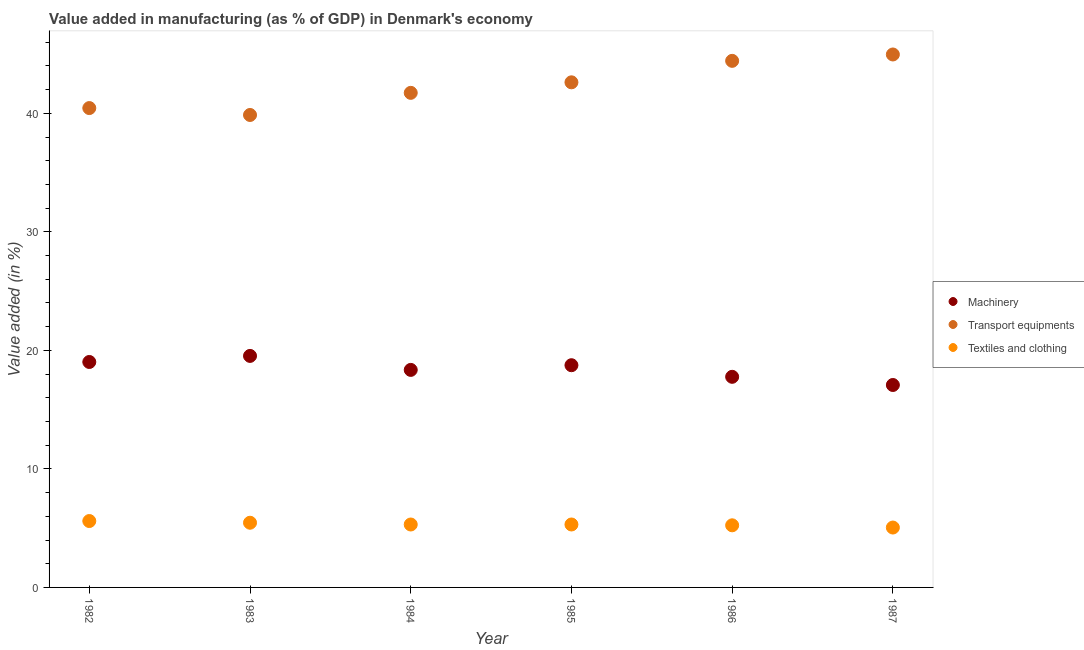What is the value added in manufacturing textile and clothing in 1986?
Make the answer very short. 5.24. Across all years, what is the maximum value added in manufacturing machinery?
Offer a terse response. 19.53. Across all years, what is the minimum value added in manufacturing machinery?
Ensure brevity in your answer.  17.08. In which year was the value added in manufacturing textile and clothing maximum?
Make the answer very short. 1982. What is the total value added in manufacturing textile and clothing in the graph?
Offer a terse response. 31.97. What is the difference between the value added in manufacturing transport equipments in 1982 and that in 1986?
Keep it short and to the point. -3.98. What is the difference between the value added in manufacturing textile and clothing in 1982 and the value added in manufacturing machinery in 1987?
Provide a short and direct response. -11.48. What is the average value added in manufacturing machinery per year?
Ensure brevity in your answer.  18.42. In the year 1986, what is the difference between the value added in manufacturing machinery and value added in manufacturing textile and clothing?
Provide a short and direct response. 12.53. What is the ratio of the value added in manufacturing textile and clothing in 1983 to that in 1986?
Offer a terse response. 1.04. Is the value added in manufacturing textile and clothing in 1984 less than that in 1986?
Offer a terse response. No. What is the difference between the highest and the second highest value added in manufacturing textile and clothing?
Ensure brevity in your answer.  0.14. What is the difference between the highest and the lowest value added in manufacturing machinery?
Your answer should be very brief. 2.45. In how many years, is the value added in manufacturing transport equipments greater than the average value added in manufacturing transport equipments taken over all years?
Make the answer very short. 3. How many dotlines are there?
Your answer should be very brief. 3. What is the difference between two consecutive major ticks on the Y-axis?
Your answer should be compact. 10. Does the graph contain grids?
Provide a short and direct response. No. How many legend labels are there?
Make the answer very short. 3. What is the title of the graph?
Keep it short and to the point. Value added in manufacturing (as % of GDP) in Denmark's economy. Does "Argument" appear as one of the legend labels in the graph?
Ensure brevity in your answer.  No. What is the label or title of the Y-axis?
Ensure brevity in your answer.  Value added (in %). What is the Value added (in %) of Machinery in 1982?
Offer a very short reply. 19.02. What is the Value added (in %) of Transport equipments in 1982?
Provide a short and direct response. 40.44. What is the Value added (in %) of Textiles and clothing in 1982?
Provide a succinct answer. 5.6. What is the Value added (in %) of Machinery in 1983?
Offer a very short reply. 19.53. What is the Value added (in %) in Transport equipments in 1983?
Your response must be concise. 39.86. What is the Value added (in %) in Textiles and clothing in 1983?
Your answer should be very brief. 5.46. What is the Value added (in %) in Machinery in 1984?
Ensure brevity in your answer.  18.35. What is the Value added (in %) of Transport equipments in 1984?
Ensure brevity in your answer.  41.73. What is the Value added (in %) in Textiles and clothing in 1984?
Your response must be concise. 5.31. What is the Value added (in %) of Machinery in 1985?
Your answer should be compact. 18.75. What is the Value added (in %) of Transport equipments in 1985?
Your answer should be very brief. 42.61. What is the Value added (in %) in Textiles and clothing in 1985?
Provide a succinct answer. 5.31. What is the Value added (in %) in Machinery in 1986?
Your answer should be compact. 17.77. What is the Value added (in %) in Transport equipments in 1986?
Make the answer very short. 44.42. What is the Value added (in %) of Textiles and clothing in 1986?
Provide a succinct answer. 5.24. What is the Value added (in %) of Machinery in 1987?
Provide a succinct answer. 17.08. What is the Value added (in %) in Transport equipments in 1987?
Your answer should be very brief. 44.96. What is the Value added (in %) in Textiles and clothing in 1987?
Offer a terse response. 5.05. Across all years, what is the maximum Value added (in %) in Machinery?
Keep it short and to the point. 19.53. Across all years, what is the maximum Value added (in %) in Transport equipments?
Make the answer very short. 44.96. Across all years, what is the maximum Value added (in %) in Textiles and clothing?
Make the answer very short. 5.6. Across all years, what is the minimum Value added (in %) in Machinery?
Your response must be concise. 17.08. Across all years, what is the minimum Value added (in %) in Transport equipments?
Give a very brief answer. 39.86. Across all years, what is the minimum Value added (in %) of Textiles and clothing?
Offer a very short reply. 5.05. What is the total Value added (in %) in Machinery in the graph?
Offer a very short reply. 110.5. What is the total Value added (in %) of Transport equipments in the graph?
Keep it short and to the point. 254.02. What is the total Value added (in %) in Textiles and clothing in the graph?
Keep it short and to the point. 31.97. What is the difference between the Value added (in %) in Machinery in 1982 and that in 1983?
Your response must be concise. -0.51. What is the difference between the Value added (in %) in Transport equipments in 1982 and that in 1983?
Offer a very short reply. 0.58. What is the difference between the Value added (in %) in Textiles and clothing in 1982 and that in 1983?
Keep it short and to the point. 0.14. What is the difference between the Value added (in %) of Machinery in 1982 and that in 1984?
Make the answer very short. 0.67. What is the difference between the Value added (in %) of Transport equipments in 1982 and that in 1984?
Your response must be concise. -1.28. What is the difference between the Value added (in %) of Textiles and clothing in 1982 and that in 1984?
Make the answer very short. 0.29. What is the difference between the Value added (in %) of Machinery in 1982 and that in 1985?
Give a very brief answer. 0.27. What is the difference between the Value added (in %) in Transport equipments in 1982 and that in 1985?
Provide a succinct answer. -2.17. What is the difference between the Value added (in %) of Textiles and clothing in 1982 and that in 1985?
Keep it short and to the point. 0.29. What is the difference between the Value added (in %) in Machinery in 1982 and that in 1986?
Make the answer very short. 1.25. What is the difference between the Value added (in %) of Transport equipments in 1982 and that in 1986?
Offer a very short reply. -3.98. What is the difference between the Value added (in %) in Textiles and clothing in 1982 and that in 1986?
Ensure brevity in your answer.  0.36. What is the difference between the Value added (in %) of Machinery in 1982 and that in 1987?
Make the answer very short. 1.94. What is the difference between the Value added (in %) in Transport equipments in 1982 and that in 1987?
Your answer should be compact. -4.52. What is the difference between the Value added (in %) in Textiles and clothing in 1982 and that in 1987?
Offer a terse response. 0.55. What is the difference between the Value added (in %) of Machinery in 1983 and that in 1984?
Provide a succinct answer. 1.18. What is the difference between the Value added (in %) in Transport equipments in 1983 and that in 1984?
Give a very brief answer. -1.87. What is the difference between the Value added (in %) of Textiles and clothing in 1983 and that in 1984?
Offer a very short reply. 0.15. What is the difference between the Value added (in %) in Machinery in 1983 and that in 1985?
Your answer should be very brief. 0.79. What is the difference between the Value added (in %) of Transport equipments in 1983 and that in 1985?
Offer a terse response. -2.75. What is the difference between the Value added (in %) in Textiles and clothing in 1983 and that in 1985?
Keep it short and to the point. 0.15. What is the difference between the Value added (in %) of Machinery in 1983 and that in 1986?
Provide a short and direct response. 1.76. What is the difference between the Value added (in %) in Transport equipments in 1983 and that in 1986?
Keep it short and to the point. -4.57. What is the difference between the Value added (in %) of Textiles and clothing in 1983 and that in 1986?
Your answer should be very brief. 0.22. What is the difference between the Value added (in %) in Machinery in 1983 and that in 1987?
Your response must be concise. 2.45. What is the difference between the Value added (in %) in Transport equipments in 1983 and that in 1987?
Ensure brevity in your answer.  -5.1. What is the difference between the Value added (in %) of Textiles and clothing in 1983 and that in 1987?
Offer a terse response. 0.41. What is the difference between the Value added (in %) of Machinery in 1984 and that in 1985?
Offer a very short reply. -0.39. What is the difference between the Value added (in %) in Transport equipments in 1984 and that in 1985?
Ensure brevity in your answer.  -0.89. What is the difference between the Value added (in %) of Textiles and clothing in 1984 and that in 1985?
Offer a very short reply. -0. What is the difference between the Value added (in %) of Machinery in 1984 and that in 1986?
Provide a succinct answer. 0.58. What is the difference between the Value added (in %) in Transport equipments in 1984 and that in 1986?
Keep it short and to the point. -2.7. What is the difference between the Value added (in %) in Textiles and clothing in 1984 and that in 1986?
Make the answer very short. 0.07. What is the difference between the Value added (in %) of Machinery in 1984 and that in 1987?
Your response must be concise. 1.27. What is the difference between the Value added (in %) in Transport equipments in 1984 and that in 1987?
Provide a succinct answer. -3.24. What is the difference between the Value added (in %) of Textiles and clothing in 1984 and that in 1987?
Keep it short and to the point. 0.26. What is the difference between the Value added (in %) of Machinery in 1985 and that in 1986?
Offer a terse response. 0.98. What is the difference between the Value added (in %) of Transport equipments in 1985 and that in 1986?
Provide a succinct answer. -1.81. What is the difference between the Value added (in %) of Textiles and clothing in 1985 and that in 1986?
Provide a succinct answer. 0.07. What is the difference between the Value added (in %) of Machinery in 1985 and that in 1987?
Your answer should be compact. 1.67. What is the difference between the Value added (in %) of Transport equipments in 1985 and that in 1987?
Make the answer very short. -2.35. What is the difference between the Value added (in %) of Textiles and clothing in 1985 and that in 1987?
Your answer should be very brief. 0.26. What is the difference between the Value added (in %) in Machinery in 1986 and that in 1987?
Your answer should be very brief. 0.69. What is the difference between the Value added (in %) in Transport equipments in 1986 and that in 1987?
Keep it short and to the point. -0.54. What is the difference between the Value added (in %) of Textiles and clothing in 1986 and that in 1987?
Offer a very short reply. 0.19. What is the difference between the Value added (in %) of Machinery in 1982 and the Value added (in %) of Transport equipments in 1983?
Offer a very short reply. -20.84. What is the difference between the Value added (in %) in Machinery in 1982 and the Value added (in %) in Textiles and clothing in 1983?
Your answer should be compact. 13.56. What is the difference between the Value added (in %) in Transport equipments in 1982 and the Value added (in %) in Textiles and clothing in 1983?
Provide a succinct answer. 34.98. What is the difference between the Value added (in %) of Machinery in 1982 and the Value added (in %) of Transport equipments in 1984?
Provide a succinct answer. -22.71. What is the difference between the Value added (in %) in Machinery in 1982 and the Value added (in %) in Textiles and clothing in 1984?
Provide a short and direct response. 13.71. What is the difference between the Value added (in %) in Transport equipments in 1982 and the Value added (in %) in Textiles and clothing in 1984?
Your answer should be compact. 35.13. What is the difference between the Value added (in %) in Machinery in 1982 and the Value added (in %) in Transport equipments in 1985?
Provide a succinct answer. -23.59. What is the difference between the Value added (in %) in Machinery in 1982 and the Value added (in %) in Textiles and clothing in 1985?
Provide a short and direct response. 13.71. What is the difference between the Value added (in %) in Transport equipments in 1982 and the Value added (in %) in Textiles and clothing in 1985?
Your answer should be very brief. 35.13. What is the difference between the Value added (in %) in Machinery in 1982 and the Value added (in %) in Transport equipments in 1986?
Offer a very short reply. -25.4. What is the difference between the Value added (in %) in Machinery in 1982 and the Value added (in %) in Textiles and clothing in 1986?
Your answer should be very brief. 13.78. What is the difference between the Value added (in %) in Transport equipments in 1982 and the Value added (in %) in Textiles and clothing in 1986?
Your answer should be very brief. 35.2. What is the difference between the Value added (in %) in Machinery in 1982 and the Value added (in %) in Transport equipments in 1987?
Ensure brevity in your answer.  -25.94. What is the difference between the Value added (in %) in Machinery in 1982 and the Value added (in %) in Textiles and clothing in 1987?
Offer a terse response. 13.97. What is the difference between the Value added (in %) in Transport equipments in 1982 and the Value added (in %) in Textiles and clothing in 1987?
Give a very brief answer. 35.39. What is the difference between the Value added (in %) of Machinery in 1983 and the Value added (in %) of Transport equipments in 1984?
Keep it short and to the point. -22.19. What is the difference between the Value added (in %) of Machinery in 1983 and the Value added (in %) of Textiles and clothing in 1984?
Keep it short and to the point. 14.22. What is the difference between the Value added (in %) in Transport equipments in 1983 and the Value added (in %) in Textiles and clothing in 1984?
Provide a succinct answer. 34.55. What is the difference between the Value added (in %) of Machinery in 1983 and the Value added (in %) of Transport equipments in 1985?
Provide a short and direct response. -23.08. What is the difference between the Value added (in %) of Machinery in 1983 and the Value added (in %) of Textiles and clothing in 1985?
Give a very brief answer. 14.22. What is the difference between the Value added (in %) in Transport equipments in 1983 and the Value added (in %) in Textiles and clothing in 1985?
Offer a terse response. 34.55. What is the difference between the Value added (in %) of Machinery in 1983 and the Value added (in %) of Transport equipments in 1986?
Your answer should be very brief. -24.89. What is the difference between the Value added (in %) of Machinery in 1983 and the Value added (in %) of Textiles and clothing in 1986?
Offer a terse response. 14.29. What is the difference between the Value added (in %) of Transport equipments in 1983 and the Value added (in %) of Textiles and clothing in 1986?
Keep it short and to the point. 34.62. What is the difference between the Value added (in %) in Machinery in 1983 and the Value added (in %) in Transport equipments in 1987?
Provide a succinct answer. -25.43. What is the difference between the Value added (in %) of Machinery in 1983 and the Value added (in %) of Textiles and clothing in 1987?
Your answer should be compact. 14.48. What is the difference between the Value added (in %) in Transport equipments in 1983 and the Value added (in %) in Textiles and clothing in 1987?
Make the answer very short. 34.81. What is the difference between the Value added (in %) of Machinery in 1984 and the Value added (in %) of Transport equipments in 1985?
Provide a succinct answer. -24.26. What is the difference between the Value added (in %) of Machinery in 1984 and the Value added (in %) of Textiles and clothing in 1985?
Offer a terse response. 13.04. What is the difference between the Value added (in %) of Transport equipments in 1984 and the Value added (in %) of Textiles and clothing in 1985?
Offer a terse response. 36.42. What is the difference between the Value added (in %) in Machinery in 1984 and the Value added (in %) in Transport equipments in 1986?
Your answer should be compact. -26.07. What is the difference between the Value added (in %) of Machinery in 1984 and the Value added (in %) of Textiles and clothing in 1986?
Ensure brevity in your answer.  13.11. What is the difference between the Value added (in %) of Transport equipments in 1984 and the Value added (in %) of Textiles and clothing in 1986?
Provide a short and direct response. 36.48. What is the difference between the Value added (in %) of Machinery in 1984 and the Value added (in %) of Transport equipments in 1987?
Your answer should be very brief. -26.61. What is the difference between the Value added (in %) in Machinery in 1984 and the Value added (in %) in Textiles and clothing in 1987?
Provide a short and direct response. 13.3. What is the difference between the Value added (in %) in Transport equipments in 1984 and the Value added (in %) in Textiles and clothing in 1987?
Your response must be concise. 36.67. What is the difference between the Value added (in %) of Machinery in 1985 and the Value added (in %) of Transport equipments in 1986?
Your answer should be compact. -25.68. What is the difference between the Value added (in %) in Machinery in 1985 and the Value added (in %) in Textiles and clothing in 1986?
Make the answer very short. 13.51. What is the difference between the Value added (in %) in Transport equipments in 1985 and the Value added (in %) in Textiles and clothing in 1986?
Your answer should be compact. 37.37. What is the difference between the Value added (in %) in Machinery in 1985 and the Value added (in %) in Transport equipments in 1987?
Your answer should be compact. -26.22. What is the difference between the Value added (in %) in Machinery in 1985 and the Value added (in %) in Textiles and clothing in 1987?
Ensure brevity in your answer.  13.69. What is the difference between the Value added (in %) in Transport equipments in 1985 and the Value added (in %) in Textiles and clothing in 1987?
Ensure brevity in your answer.  37.56. What is the difference between the Value added (in %) of Machinery in 1986 and the Value added (in %) of Transport equipments in 1987?
Give a very brief answer. -27.19. What is the difference between the Value added (in %) of Machinery in 1986 and the Value added (in %) of Textiles and clothing in 1987?
Give a very brief answer. 12.72. What is the difference between the Value added (in %) of Transport equipments in 1986 and the Value added (in %) of Textiles and clothing in 1987?
Offer a very short reply. 39.37. What is the average Value added (in %) in Machinery per year?
Offer a terse response. 18.42. What is the average Value added (in %) of Transport equipments per year?
Your response must be concise. 42.34. What is the average Value added (in %) in Textiles and clothing per year?
Give a very brief answer. 5.33. In the year 1982, what is the difference between the Value added (in %) of Machinery and Value added (in %) of Transport equipments?
Offer a very short reply. -21.42. In the year 1982, what is the difference between the Value added (in %) in Machinery and Value added (in %) in Textiles and clothing?
Provide a succinct answer. 13.42. In the year 1982, what is the difference between the Value added (in %) of Transport equipments and Value added (in %) of Textiles and clothing?
Your answer should be very brief. 34.84. In the year 1983, what is the difference between the Value added (in %) in Machinery and Value added (in %) in Transport equipments?
Offer a very short reply. -20.33. In the year 1983, what is the difference between the Value added (in %) in Machinery and Value added (in %) in Textiles and clothing?
Your answer should be very brief. 14.07. In the year 1983, what is the difference between the Value added (in %) in Transport equipments and Value added (in %) in Textiles and clothing?
Offer a terse response. 34.4. In the year 1984, what is the difference between the Value added (in %) in Machinery and Value added (in %) in Transport equipments?
Your answer should be very brief. -23.37. In the year 1984, what is the difference between the Value added (in %) in Machinery and Value added (in %) in Textiles and clothing?
Offer a very short reply. 13.04. In the year 1984, what is the difference between the Value added (in %) in Transport equipments and Value added (in %) in Textiles and clothing?
Provide a short and direct response. 36.42. In the year 1985, what is the difference between the Value added (in %) in Machinery and Value added (in %) in Transport equipments?
Your answer should be compact. -23.87. In the year 1985, what is the difference between the Value added (in %) in Machinery and Value added (in %) in Textiles and clothing?
Provide a succinct answer. 13.44. In the year 1985, what is the difference between the Value added (in %) in Transport equipments and Value added (in %) in Textiles and clothing?
Your answer should be very brief. 37.3. In the year 1986, what is the difference between the Value added (in %) in Machinery and Value added (in %) in Transport equipments?
Your answer should be very brief. -26.66. In the year 1986, what is the difference between the Value added (in %) of Machinery and Value added (in %) of Textiles and clothing?
Your answer should be compact. 12.53. In the year 1986, what is the difference between the Value added (in %) in Transport equipments and Value added (in %) in Textiles and clothing?
Your answer should be very brief. 39.18. In the year 1987, what is the difference between the Value added (in %) of Machinery and Value added (in %) of Transport equipments?
Make the answer very short. -27.88. In the year 1987, what is the difference between the Value added (in %) of Machinery and Value added (in %) of Textiles and clothing?
Offer a terse response. 12.03. In the year 1987, what is the difference between the Value added (in %) in Transport equipments and Value added (in %) in Textiles and clothing?
Your answer should be very brief. 39.91. What is the ratio of the Value added (in %) in Machinery in 1982 to that in 1983?
Offer a terse response. 0.97. What is the ratio of the Value added (in %) in Transport equipments in 1982 to that in 1983?
Keep it short and to the point. 1.01. What is the ratio of the Value added (in %) in Textiles and clothing in 1982 to that in 1983?
Provide a succinct answer. 1.03. What is the ratio of the Value added (in %) of Machinery in 1982 to that in 1984?
Keep it short and to the point. 1.04. What is the ratio of the Value added (in %) of Transport equipments in 1982 to that in 1984?
Make the answer very short. 0.97. What is the ratio of the Value added (in %) in Textiles and clothing in 1982 to that in 1984?
Keep it short and to the point. 1.06. What is the ratio of the Value added (in %) of Machinery in 1982 to that in 1985?
Give a very brief answer. 1.01. What is the ratio of the Value added (in %) in Transport equipments in 1982 to that in 1985?
Provide a short and direct response. 0.95. What is the ratio of the Value added (in %) of Textiles and clothing in 1982 to that in 1985?
Your response must be concise. 1.05. What is the ratio of the Value added (in %) in Machinery in 1982 to that in 1986?
Keep it short and to the point. 1.07. What is the ratio of the Value added (in %) in Transport equipments in 1982 to that in 1986?
Ensure brevity in your answer.  0.91. What is the ratio of the Value added (in %) in Textiles and clothing in 1982 to that in 1986?
Your response must be concise. 1.07. What is the ratio of the Value added (in %) of Machinery in 1982 to that in 1987?
Keep it short and to the point. 1.11. What is the ratio of the Value added (in %) of Transport equipments in 1982 to that in 1987?
Provide a short and direct response. 0.9. What is the ratio of the Value added (in %) of Textiles and clothing in 1982 to that in 1987?
Your answer should be compact. 1.11. What is the ratio of the Value added (in %) of Machinery in 1983 to that in 1984?
Offer a very short reply. 1.06. What is the ratio of the Value added (in %) of Transport equipments in 1983 to that in 1984?
Your answer should be compact. 0.96. What is the ratio of the Value added (in %) of Textiles and clothing in 1983 to that in 1984?
Keep it short and to the point. 1.03. What is the ratio of the Value added (in %) in Machinery in 1983 to that in 1985?
Offer a very short reply. 1.04. What is the ratio of the Value added (in %) in Transport equipments in 1983 to that in 1985?
Ensure brevity in your answer.  0.94. What is the ratio of the Value added (in %) in Textiles and clothing in 1983 to that in 1985?
Your answer should be very brief. 1.03. What is the ratio of the Value added (in %) in Machinery in 1983 to that in 1986?
Your response must be concise. 1.1. What is the ratio of the Value added (in %) of Transport equipments in 1983 to that in 1986?
Provide a succinct answer. 0.9. What is the ratio of the Value added (in %) of Textiles and clothing in 1983 to that in 1986?
Offer a very short reply. 1.04. What is the ratio of the Value added (in %) of Machinery in 1983 to that in 1987?
Your answer should be very brief. 1.14. What is the ratio of the Value added (in %) in Transport equipments in 1983 to that in 1987?
Offer a very short reply. 0.89. What is the ratio of the Value added (in %) of Textiles and clothing in 1983 to that in 1987?
Provide a succinct answer. 1.08. What is the ratio of the Value added (in %) in Machinery in 1984 to that in 1985?
Offer a terse response. 0.98. What is the ratio of the Value added (in %) of Transport equipments in 1984 to that in 1985?
Provide a short and direct response. 0.98. What is the ratio of the Value added (in %) in Textiles and clothing in 1984 to that in 1985?
Your answer should be very brief. 1. What is the ratio of the Value added (in %) in Machinery in 1984 to that in 1986?
Provide a short and direct response. 1.03. What is the ratio of the Value added (in %) in Transport equipments in 1984 to that in 1986?
Keep it short and to the point. 0.94. What is the ratio of the Value added (in %) in Machinery in 1984 to that in 1987?
Keep it short and to the point. 1.07. What is the ratio of the Value added (in %) of Transport equipments in 1984 to that in 1987?
Offer a terse response. 0.93. What is the ratio of the Value added (in %) in Textiles and clothing in 1984 to that in 1987?
Your answer should be very brief. 1.05. What is the ratio of the Value added (in %) in Machinery in 1985 to that in 1986?
Offer a very short reply. 1.06. What is the ratio of the Value added (in %) of Transport equipments in 1985 to that in 1986?
Provide a succinct answer. 0.96. What is the ratio of the Value added (in %) of Textiles and clothing in 1985 to that in 1986?
Ensure brevity in your answer.  1.01. What is the ratio of the Value added (in %) in Machinery in 1985 to that in 1987?
Give a very brief answer. 1.1. What is the ratio of the Value added (in %) in Transport equipments in 1985 to that in 1987?
Make the answer very short. 0.95. What is the ratio of the Value added (in %) of Textiles and clothing in 1985 to that in 1987?
Your response must be concise. 1.05. What is the ratio of the Value added (in %) in Machinery in 1986 to that in 1987?
Your answer should be very brief. 1.04. What is the ratio of the Value added (in %) of Transport equipments in 1986 to that in 1987?
Make the answer very short. 0.99. What is the ratio of the Value added (in %) of Textiles and clothing in 1986 to that in 1987?
Ensure brevity in your answer.  1.04. What is the difference between the highest and the second highest Value added (in %) in Machinery?
Provide a short and direct response. 0.51. What is the difference between the highest and the second highest Value added (in %) of Transport equipments?
Your response must be concise. 0.54. What is the difference between the highest and the second highest Value added (in %) of Textiles and clothing?
Make the answer very short. 0.14. What is the difference between the highest and the lowest Value added (in %) of Machinery?
Make the answer very short. 2.45. What is the difference between the highest and the lowest Value added (in %) of Transport equipments?
Your answer should be compact. 5.1. What is the difference between the highest and the lowest Value added (in %) of Textiles and clothing?
Provide a short and direct response. 0.55. 